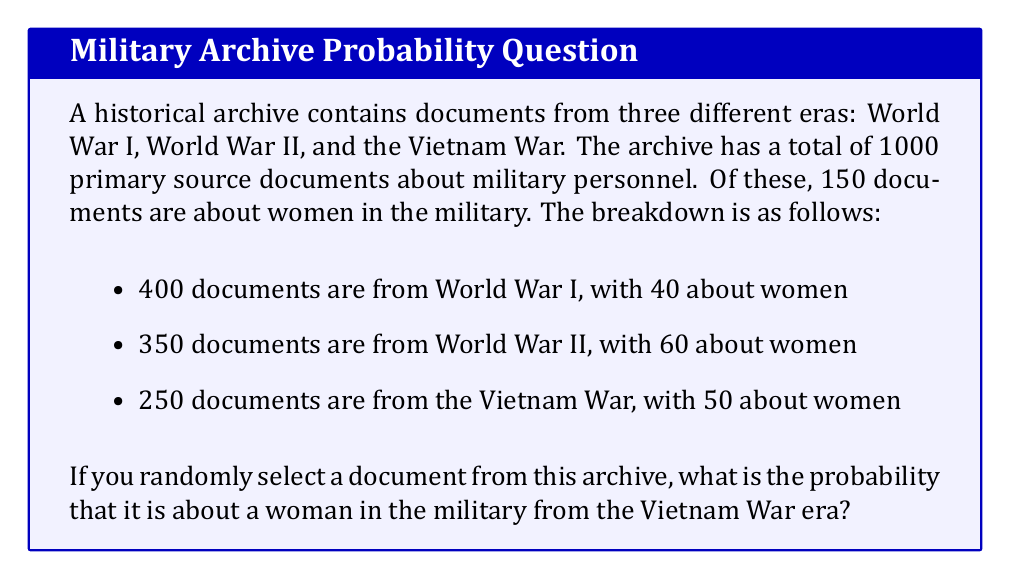Could you help me with this problem? To solve this problem, we need to use the concept of conditional probability. We're looking for the probability of selecting a document that satisfies two conditions: it's about a woman in the military AND it's from the Vietnam War era.

Let's break this down step-by-step:

1) First, let's calculate the probability of selecting a document from the Vietnam War era:

   $P(\text{Vietnam War}) = \frac{\text{Vietnam War documents}}{\text{Total documents}} = \frac{250}{1000} = 0.25$

2) Now, we need to find the probability that a document is about a woman in the military, given that it's from the Vietnam War era:

   $P(\text{Woman | Vietnam War}) = \frac{\text{Documents about women from Vietnam War}}{\text{Total Vietnam War documents}} = \frac{50}{250} = 0.2$

3) The probability we're looking for is the product of these two probabilities:

   $P(\text{Woman and Vietnam War}) = P(\text{Vietnam War}) \times P(\text{Woman | Vietnam War})$

4) Substituting the values:

   $P(\text{Woman and Vietnam War}) = 0.25 \times 0.2 = 0.05$

Therefore, the probability of randomly selecting a document about a woman in the military from the Vietnam War era is 0.05 or 5%.
Answer: 0.05 or 5% 